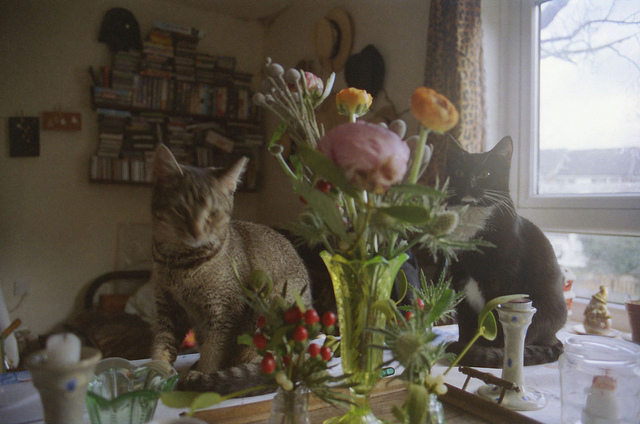<image>What type of bottle is near the cat? I am not sure what type of bottle is near the cat. It can be a vase, wine, flower, or candle. What type of bottle is near the cat? It is difficult to determine what type of bottle is near the cat. It can be a vase, a wine bottle, or a candle. 